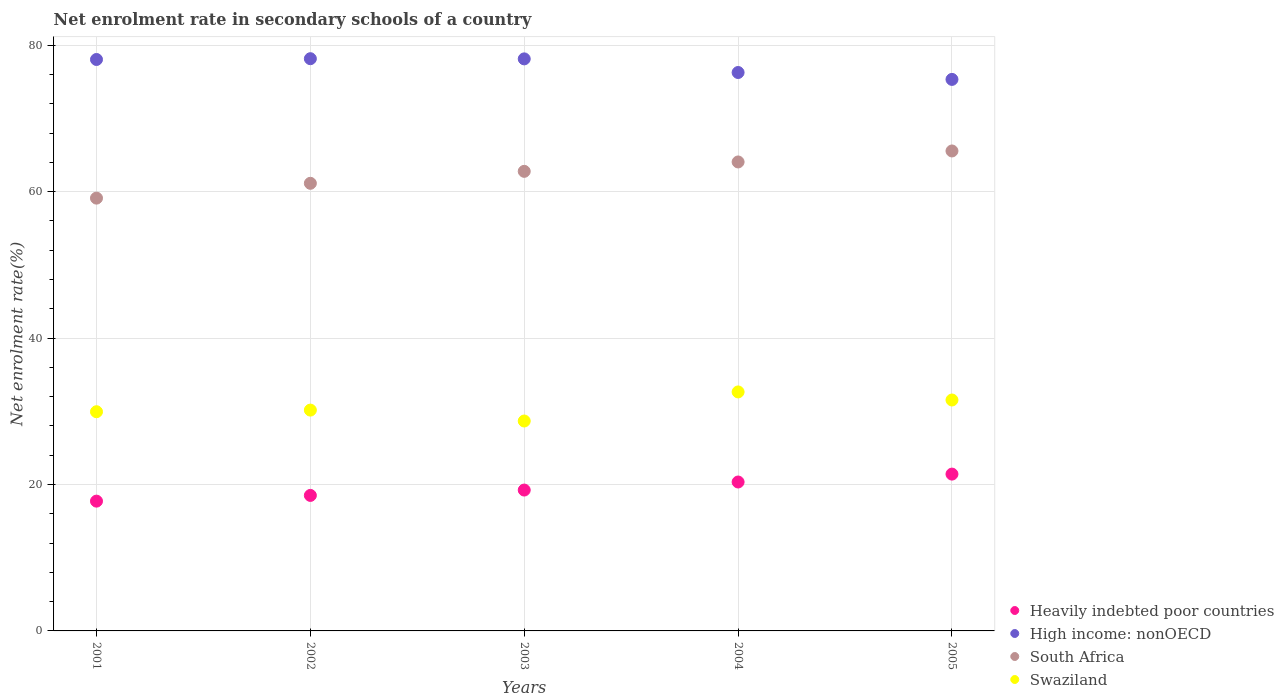Is the number of dotlines equal to the number of legend labels?
Make the answer very short. Yes. What is the net enrolment rate in secondary schools in Swaziland in 2001?
Keep it short and to the point. 29.94. Across all years, what is the maximum net enrolment rate in secondary schools in Heavily indebted poor countries?
Offer a terse response. 21.42. Across all years, what is the minimum net enrolment rate in secondary schools in High income: nonOECD?
Your response must be concise. 75.33. What is the total net enrolment rate in secondary schools in High income: nonOECD in the graph?
Provide a short and direct response. 385.93. What is the difference between the net enrolment rate in secondary schools in Swaziland in 2001 and that in 2003?
Ensure brevity in your answer.  1.27. What is the difference between the net enrolment rate in secondary schools in South Africa in 2001 and the net enrolment rate in secondary schools in Heavily indebted poor countries in 2005?
Your answer should be very brief. 37.69. What is the average net enrolment rate in secondary schools in South Africa per year?
Offer a terse response. 62.52. In the year 2001, what is the difference between the net enrolment rate in secondary schools in Swaziland and net enrolment rate in secondary schools in High income: nonOECD?
Offer a very short reply. -48.11. What is the ratio of the net enrolment rate in secondary schools in Heavily indebted poor countries in 2002 to that in 2005?
Provide a succinct answer. 0.86. What is the difference between the highest and the second highest net enrolment rate in secondary schools in High income: nonOECD?
Offer a very short reply. 0.02. What is the difference between the highest and the lowest net enrolment rate in secondary schools in High income: nonOECD?
Your response must be concise. 2.83. In how many years, is the net enrolment rate in secondary schools in South Africa greater than the average net enrolment rate in secondary schools in South Africa taken over all years?
Keep it short and to the point. 3. Is the sum of the net enrolment rate in secondary schools in Heavily indebted poor countries in 2003 and 2004 greater than the maximum net enrolment rate in secondary schools in Swaziland across all years?
Ensure brevity in your answer.  Yes. Is it the case that in every year, the sum of the net enrolment rate in secondary schools in Swaziland and net enrolment rate in secondary schools in South Africa  is greater than the sum of net enrolment rate in secondary schools in Heavily indebted poor countries and net enrolment rate in secondary schools in High income: nonOECD?
Make the answer very short. No. Does the net enrolment rate in secondary schools in Heavily indebted poor countries monotonically increase over the years?
Offer a very short reply. Yes. What is the difference between two consecutive major ticks on the Y-axis?
Keep it short and to the point. 20. Where does the legend appear in the graph?
Provide a short and direct response. Bottom right. How are the legend labels stacked?
Offer a very short reply. Vertical. What is the title of the graph?
Make the answer very short. Net enrolment rate in secondary schools of a country. Does "Trinidad and Tobago" appear as one of the legend labels in the graph?
Ensure brevity in your answer.  No. What is the label or title of the Y-axis?
Offer a terse response. Net enrolment rate(%). What is the Net enrolment rate(%) in Heavily indebted poor countries in 2001?
Provide a succinct answer. 17.73. What is the Net enrolment rate(%) in High income: nonOECD in 2001?
Give a very brief answer. 78.05. What is the Net enrolment rate(%) in South Africa in 2001?
Provide a succinct answer. 59.11. What is the Net enrolment rate(%) of Swaziland in 2001?
Ensure brevity in your answer.  29.94. What is the Net enrolment rate(%) of Heavily indebted poor countries in 2002?
Provide a short and direct response. 18.51. What is the Net enrolment rate(%) in High income: nonOECD in 2002?
Your answer should be compact. 78.16. What is the Net enrolment rate(%) of South Africa in 2002?
Provide a short and direct response. 61.14. What is the Net enrolment rate(%) in Swaziland in 2002?
Your answer should be compact. 30.16. What is the Net enrolment rate(%) of Heavily indebted poor countries in 2003?
Offer a very short reply. 19.24. What is the Net enrolment rate(%) in High income: nonOECD in 2003?
Offer a terse response. 78.13. What is the Net enrolment rate(%) in South Africa in 2003?
Provide a succinct answer. 62.77. What is the Net enrolment rate(%) of Swaziland in 2003?
Provide a short and direct response. 28.67. What is the Net enrolment rate(%) in Heavily indebted poor countries in 2004?
Provide a short and direct response. 20.34. What is the Net enrolment rate(%) of High income: nonOECD in 2004?
Keep it short and to the point. 76.27. What is the Net enrolment rate(%) of South Africa in 2004?
Keep it short and to the point. 64.05. What is the Net enrolment rate(%) in Swaziland in 2004?
Your answer should be very brief. 32.64. What is the Net enrolment rate(%) of Heavily indebted poor countries in 2005?
Provide a short and direct response. 21.42. What is the Net enrolment rate(%) in High income: nonOECD in 2005?
Give a very brief answer. 75.33. What is the Net enrolment rate(%) of South Africa in 2005?
Offer a terse response. 65.55. What is the Net enrolment rate(%) in Swaziland in 2005?
Keep it short and to the point. 31.54. Across all years, what is the maximum Net enrolment rate(%) of Heavily indebted poor countries?
Offer a very short reply. 21.42. Across all years, what is the maximum Net enrolment rate(%) in High income: nonOECD?
Your response must be concise. 78.16. Across all years, what is the maximum Net enrolment rate(%) of South Africa?
Offer a terse response. 65.55. Across all years, what is the maximum Net enrolment rate(%) in Swaziland?
Your answer should be compact. 32.64. Across all years, what is the minimum Net enrolment rate(%) in Heavily indebted poor countries?
Make the answer very short. 17.73. Across all years, what is the minimum Net enrolment rate(%) in High income: nonOECD?
Provide a succinct answer. 75.33. Across all years, what is the minimum Net enrolment rate(%) of South Africa?
Offer a very short reply. 59.11. Across all years, what is the minimum Net enrolment rate(%) of Swaziland?
Provide a short and direct response. 28.67. What is the total Net enrolment rate(%) of Heavily indebted poor countries in the graph?
Ensure brevity in your answer.  97.23. What is the total Net enrolment rate(%) in High income: nonOECD in the graph?
Give a very brief answer. 385.93. What is the total Net enrolment rate(%) in South Africa in the graph?
Make the answer very short. 312.62. What is the total Net enrolment rate(%) in Swaziland in the graph?
Provide a succinct answer. 152.95. What is the difference between the Net enrolment rate(%) of Heavily indebted poor countries in 2001 and that in 2002?
Offer a terse response. -0.78. What is the difference between the Net enrolment rate(%) in High income: nonOECD in 2001 and that in 2002?
Your answer should be very brief. -0.11. What is the difference between the Net enrolment rate(%) of South Africa in 2001 and that in 2002?
Make the answer very short. -2.02. What is the difference between the Net enrolment rate(%) of Swaziland in 2001 and that in 2002?
Offer a very short reply. -0.22. What is the difference between the Net enrolment rate(%) in Heavily indebted poor countries in 2001 and that in 2003?
Provide a short and direct response. -1.51. What is the difference between the Net enrolment rate(%) of High income: nonOECD in 2001 and that in 2003?
Your response must be concise. -0.08. What is the difference between the Net enrolment rate(%) in South Africa in 2001 and that in 2003?
Your response must be concise. -3.66. What is the difference between the Net enrolment rate(%) of Swaziland in 2001 and that in 2003?
Give a very brief answer. 1.27. What is the difference between the Net enrolment rate(%) in Heavily indebted poor countries in 2001 and that in 2004?
Keep it short and to the point. -2.61. What is the difference between the Net enrolment rate(%) of High income: nonOECD in 2001 and that in 2004?
Make the answer very short. 1.78. What is the difference between the Net enrolment rate(%) of South Africa in 2001 and that in 2004?
Your answer should be compact. -4.94. What is the difference between the Net enrolment rate(%) of Swaziland in 2001 and that in 2004?
Offer a terse response. -2.7. What is the difference between the Net enrolment rate(%) of Heavily indebted poor countries in 2001 and that in 2005?
Provide a short and direct response. -3.69. What is the difference between the Net enrolment rate(%) in High income: nonOECD in 2001 and that in 2005?
Give a very brief answer. 2.72. What is the difference between the Net enrolment rate(%) of South Africa in 2001 and that in 2005?
Make the answer very short. -6.44. What is the difference between the Net enrolment rate(%) in Swaziland in 2001 and that in 2005?
Give a very brief answer. -1.6. What is the difference between the Net enrolment rate(%) in Heavily indebted poor countries in 2002 and that in 2003?
Provide a succinct answer. -0.73. What is the difference between the Net enrolment rate(%) in High income: nonOECD in 2002 and that in 2003?
Give a very brief answer. 0.02. What is the difference between the Net enrolment rate(%) of South Africa in 2002 and that in 2003?
Keep it short and to the point. -1.63. What is the difference between the Net enrolment rate(%) in Swaziland in 2002 and that in 2003?
Make the answer very short. 1.49. What is the difference between the Net enrolment rate(%) of Heavily indebted poor countries in 2002 and that in 2004?
Offer a very short reply. -1.83. What is the difference between the Net enrolment rate(%) in High income: nonOECD in 2002 and that in 2004?
Provide a succinct answer. 1.89. What is the difference between the Net enrolment rate(%) of South Africa in 2002 and that in 2004?
Your answer should be very brief. -2.92. What is the difference between the Net enrolment rate(%) in Swaziland in 2002 and that in 2004?
Provide a succinct answer. -2.48. What is the difference between the Net enrolment rate(%) in Heavily indebted poor countries in 2002 and that in 2005?
Ensure brevity in your answer.  -2.91. What is the difference between the Net enrolment rate(%) of High income: nonOECD in 2002 and that in 2005?
Provide a short and direct response. 2.83. What is the difference between the Net enrolment rate(%) of South Africa in 2002 and that in 2005?
Provide a succinct answer. -4.42. What is the difference between the Net enrolment rate(%) of Swaziland in 2002 and that in 2005?
Provide a succinct answer. -1.38. What is the difference between the Net enrolment rate(%) of Heavily indebted poor countries in 2003 and that in 2004?
Make the answer very short. -1.1. What is the difference between the Net enrolment rate(%) in High income: nonOECD in 2003 and that in 2004?
Offer a very short reply. 1.86. What is the difference between the Net enrolment rate(%) in South Africa in 2003 and that in 2004?
Your answer should be very brief. -1.28. What is the difference between the Net enrolment rate(%) of Swaziland in 2003 and that in 2004?
Your response must be concise. -3.97. What is the difference between the Net enrolment rate(%) in Heavily indebted poor countries in 2003 and that in 2005?
Your answer should be very brief. -2.18. What is the difference between the Net enrolment rate(%) of High income: nonOECD in 2003 and that in 2005?
Your response must be concise. 2.8. What is the difference between the Net enrolment rate(%) of South Africa in 2003 and that in 2005?
Offer a very short reply. -2.78. What is the difference between the Net enrolment rate(%) of Swaziland in 2003 and that in 2005?
Keep it short and to the point. -2.87. What is the difference between the Net enrolment rate(%) in Heavily indebted poor countries in 2004 and that in 2005?
Provide a short and direct response. -1.08. What is the difference between the Net enrolment rate(%) in High income: nonOECD in 2004 and that in 2005?
Provide a short and direct response. 0.94. What is the difference between the Net enrolment rate(%) in Swaziland in 2004 and that in 2005?
Ensure brevity in your answer.  1.1. What is the difference between the Net enrolment rate(%) in Heavily indebted poor countries in 2001 and the Net enrolment rate(%) in High income: nonOECD in 2002?
Keep it short and to the point. -60.43. What is the difference between the Net enrolment rate(%) in Heavily indebted poor countries in 2001 and the Net enrolment rate(%) in South Africa in 2002?
Your answer should be very brief. -43.41. What is the difference between the Net enrolment rate(%) in Heavily indebted poor countries in 2001 and the Net enrolment rate(%) in Swaziland in 2002?
Make the answer very short. -12.43. What is the difference between the Net enrolment rate(%) in High income: nonOECD in 2001 and the Net enrolment rate(%) in South Africa in 2002?
Your answer should be very brief. 16.91. What is the difference between the Net enrolment rate(%) of High income: nonOECD in 2001 and the Net enrolment rate(%) of Swaziland in 2002?
Keep it short and to the point. 47.89. What is the difference between the Net enrolment rate(%) in South Africa in 2001 and the Net enrolment rate(%) in Swaziland in 2002?
Offer a terse response. 28.95. What is the difference between the Net enrolment rate(%) of Heavily indebted poor countries in 2001 and the Net enrolment rate(%) of High income: nonOECD in 2003?
Make the answer very short. -60.4. What is the difference between the Net enrolment rate(%) in Heavily indebted poor countries in 2001 and the Net enrolment rate(%) in South Africa in 2003?
Offer a very short reply. -45.04. What is the difference between the Net enrolment rate(%) in Heavily indebted poor countries in 2001 and the Net enrolment rate(%) in Swaziland in 2003?
Provide a short and direct response. -10.94. What is the difference between the Net enrolment rate(%) in High income: nonOECD in 2001 and the Net enrolment rate(%) in South Africa in 2003?
Your answer should be very brief. 15.28. What is the difference between the Net enrolment rate(%) of High income: nonOECD in 2001 and the Net enrolment rate(%) of Swaziland in 2003?
Keep it short and to the point. 49.38. What is the difference between the Net enrolment rate(%) of South Africa in 2001 and the Net enrolment rate(%) of Swaziland in 2003?
Provide a succinct answer. 30.44. What is the difference between the Net enrolment rate(%) of Heavily indebted poor countries in 2001 and the Net enrolment rate(%) of High income: nonOECD in 2004?
Offer a terse response. -58.54. What is the difference between the Net enrolment rate(%) in Heavily indebted poor countries in 2001 and the Net enrolment rate(%) in South Africa in 2004?
Offer a terse response. -46.33. What is the difference between the Net enrolment rate(%) of Heavily indebted poor countries in 2001 and the Net enrolment rate(%) of Swaziland in 2004?
Your answer should be compact. -14.92. What is the difference between the Net enrolment rate(%) in High income: nonOECD in 2001 and the Net enrolment rate(%) in South Africa in 2004?
Keep it short and to the point. 13.99. What is the difference between the Net enrolment rate(%) in High income: nonOECD in 2001 and the Net enrolment rate(%) in Swaziland in 2004?
Ensure brevity in your answer.  45.4. What is the difference between the Net enrolment rate(%) of South Africa in 2001 and the Net enrolment rate(%) of Swaziland in 2004?
Make the answer very short. 26.47. What is the difference between the Net enrolment rate(%) in Heavily indebted poor countries in 2001 and the Net enrolment rate(%) in High income: nonOECD in 2005?
Provide a short and direct response. -57.6. What is the difference between the Net enrolment rate(%) in Heavily indebted poor countries in 2001 and the Net enrolment rate(%) in South Africa in 2005?
Your response must be concise. -47.83. What is the difference between the Net enrolment rate(%) in Heavily indebted poor countries in 2001 and the Net enrolment rate(%) in Swaziland in 2005?
Offer a terse response. -13.81. What is the difference between the Net enrolment rate(%) of High income: nonOECD in 2001 and the Net enrolment rate(%) of South Africa in 2005?
Ensure brevity in your answer.  12.49. What is the difference between the Net enrolment rate(%) of High income: nonOECD in 2001 and the Net enrolment rate(%) of Swaziland in 2005?
Make the answer very short. 46.51. What is the difference between the Net enrolment rate(%) of South Africa in 2001 and the Net enrolment rate(%) of Swaziland in 2005?
Your answer should be compact. 27.57. What is the difference between the Net enrolment rate(%) in Heavily indebted poor countries in 2002 and the Net enrolment rate(%) in High income: nonOECD in 2003?
Provide a succinct answer. -59.62. What is the difference between the Net enrolment rate(%) of Heavily indebted poor countries in 2002 and the Net enrolment rate(%) of South Africa in 2003?
Give a very brief answer. -44.26. What is the difference between the Net enrolment rate(%) in Heavily indebted poor countries in 2002 and the Net enrolment rate(%) in Swaziland in 2003?
Offer a terse response. -10.16. What is the difference between the Net enrolment rate(%) of High income: nonOECD in 2002 and the Net enrolment rate(%) of South Africa in 2003?
Ensure brevity in your answer.  15.39. What is the difference between the Net enrolment rate(%) of High income: nonOECD in 2002 and the Net enrolment rate(%) of Swaziland in 2003?
Make the answer very short. 49.48. What is the difference between the Net enrolment rate(%) of South Africa in 2002 and the Net enrolment rate(%) of Swaziland in 2003?
Offer a terse response. 32.47. What is the difference between the Net enrolment rate(%) in Heavily indebted poor countries in 2002 and the Net enrolment rate(%) in High income: nonOECD in 2004?
Offer a terse response. -57.76. What is the difference between the Net enrolment rate(%) of Heavily indebted poor countries in 2002 and the Net enrolment rate(%) of South Africa in 2004?
Keep it short and to the point. -45.55. What is the difference between the Net enrolment rate(%) of Heavily indebted poor countries in 2002 and the Net enrolment rate(%) of Swaziland in 2004?
Provide a succinct answer. -14.13. What is the difference between the Net enrolment rate(%) of High income: nonOECD in 2002 and the Net enrolment rate(%) of South Africa in 2004?
Your response must be concise. 14.1. What is the difference between the Net enrolment rate(%) of High income: nonOECD in 2002 and the Net enrolment rate(%) of Swaziland in 2004?
Provide a short and direct response. 45.51. What is the difference between the Net enrolment rate(%) in South Africa in 2002 and the Net enrolment rate(%) in Swaziland in 2004?
Your answer should be very brief. 28.49. What is the difference between the Net enrolment rate(%) in Heavily indebted poor countries in 2002 and the Net enrolment rate(%) in High income: nonOECD in 2005?
Your response must be concise. -56.82. What is the difference between the Net enrolment rate(%) of Heavily indebted poor countries in 2002 and the Net enrolment rate(%) of South Africa in 2005?
Give a very brief answer. -47.05. What is the difference between the Net enrolment rate(%) of Heavily indebted poor countries in 2002 and the Net enrolment rate(%) of Swaziland in 2005?
Your response must be concise. -13.03. What is the difference between the Net enrolment rate(%) of High income: nonOECD in 2002 and the Net enrolment rate(%) of South Africa in 2005?
Offer a terse response. 12.6. What is the difference between the Net enrolment rate(%) in High income: nonOECD in 2002 and the Net enrolment rate(%) in Swaziland in 2005?
Ensure brevity in your answer.  46.62. What is the difference between the Net enrolment rate(%) of South Africa in 2002 and the Net enrolment rate(%) of Swaziland in 2005?
Give a very brief answer. 29.6. What is the difference between the Net enrolment rate(%) in Heavily indebted poor countries in 2003 and the Net enrolment rate(%) in High income: nonOECD in 2004?
Make the answer very short. -57.03. What is the difference between the Net enrolment rate(%) of Heavily indebted poor countries in 2003 and the Net enrolment rate(%) of South Africa in 2004?
Give a very brief answer. -44.81. What is the difference between the Net enrolment rate(%) in Heavily indebted poor countries in 2003 and the Net enrolment rate(%) in Swaziland in 2004?
Your response must be concise. -13.4. What is the difference between the Net enrolment rate(%) in High income: nonOECD in 2003 and the Net enrolment rate(%) in South Africa in 2004?
Ensure brevity in your answer.  14.08. What is the difference between the Net enrolment rate(%) of High income: nonOECD in 2003 and the Net enrolment rate(%) of Swaziland in 2004?
Your answer should be very brief. 45.49. What is the difference between the Net enrolment rate(%) in South Africa in 2003 and the Net enrolment rate(%) in Swaziland in 2004?
Your response must be concise. 30.13. What is the difference between the Net enrolment rate(%) of Heavily indebted poor countries in 2003 and the Net enrolment rate(%) of High income: nonOECD in 2005?
Give a very brief answer. -56.09. What is the difference between the Net enrolment rate(%) in Heavily indebted poor countries in 2003 and the Net enrolment rate(%) in South Africa in 2005?
Your response must be concise. -46.31. What is the difference between the Net enrolment rate(%) of High income: nonOECD in 2003 and the Net enrolment rate(%) of South Africa in 2005?
Offer a terse response. 12.58. What is the difference between the Net enrolment rate(%) in High income: nonOECD in 2003 and the Net enrolment rate(%) in Swaziland in 2005?
Your response must be concise. 46.59. What is the difference between the Net enrolment rate(%) in South Africa in 2003 and the Net enrolment rate(%) in Swaziland in 2005?
Your answer should be very brief. 31.23. What is the difference between the Net enrolment rate(%) in Heavily indebted poor countries in 2004 and the Net enrolment rate(%) in High income: nonOECD in 2005?
Provide a succinct answer. -54.99. What is the difference between the Net enrolment rate(%) of Heavily indebted poor countries in 2004 and the Net enrolment rate(%) of South Africa in 2005?
Your answer should be compact. -45.21. What is the difference between the Net enrolment rate(%) of Heavily indebted poor countries in 2004 and the Net enrolment rate(%) of Swaziland in 2005?
Provide a short and direct response. -11.2. What is the difference between the Net enrolment rate(%) of High income: nonOECD in 2004 and the Net enrolment rate(%) of South Africa in 2005?
Your answer should be compact. 10.72. What is the difference between the Net enrolment rate(%) in High income: nonOECD in 2004 and the Net enrolment rate(%) in Swaziland in 2005?
Offer a terse response. 44.73. What is the difference between the Net enrolment rate(%) in South Africa in 2004 and the Net enrolment rate(%) in Swaziland in 2005?
Your response must be concise. 32.51. What is the average Net enrolment rate(%) in Heavily indebted poor countries per year?
Keep it short and to the point. 19.45. What is the average Net enrolment rate(%) of High income: nonOECD per year?
Make the answer very short. 77.19. What is the average Net enrolment rate(%) of South Africa per year?
Make the answer very short. 62.52. What is the average Net enrolment rate(%) of Swaziland per year?
Offer a very short reply. 30.59. In the year 2001, what is the difference between the Net enrolment rate(%) of Heavily indebted poor countries and Net enrolment rate(%) of High income: nonOECD?
Your response must be concise. -60.32. In the year 2001, what is the difference between the Net enrolment rate(%) in Heavily indebted poor countries and Net enrolment rate(%) in South Africa?
Your response must be concise. -41.39. In the year 2001, what is the difference between the Net enrolment rate(%) of Heavily indebted poor countries and Net enrolment rate(%) of Swaziland?
Provide a short and direct response. -12.21. In the year 2001, what is the difference between the Net enrolment rate(%) in High income: nonOECD and Net enrolment rate(%) in South Africa?
Make the answer very short. 18.94. In the year 2001, what is the difference between the Net enrolment rate(%) of High income: nonOECD and Net enrolment rate(%) of Swaziland?
Offer a terse response. 48.11. In the year 2001, what is the difference between the Net enrolment rate(%) of South Africa and Net enrolment rate(%) of Swaziland?
Your answer should be very brief. 29.17. In the year 2002, what is the difference between the Net enrolment rate(%) in Heavily indebted poor countries and Net enrolment rate(%) in High income: nonOECD?
Offer a terse response. -59.65. In the year 2002, what is the difference between the Net enrolment rate(%) of Heavily indebted poor countries and Net enrolment rate(%) of South Africa?
Give a very brief answer. -42.63. In the year 2002, what is the difference between the Net enrolment rate(%) in Heavily indebted poor countries and Net enrolment rate(%) in Swaziland?
Provide a succinct answer. -11.65. In the year 2002, what is the difference between the Net enrolment rate(%) of High income: nonOECD and Net enrolment rate(%) of South Africa?
Your response must be concise. 17.02. In the year 2002, what is the difference between the Net enrolment rate(%) of High income: nonOECD and Net enrolment rate(%) of Swaziland?
Offer a very short reply. 47.99. In the year 2002, what is the difference between the Net enrolment rate(%) in South Africa and Net enrolment rate(%) in Swaziland?
Provide a succinct answer. 30.98. In the year 2003, what is the difference between the Net enrolment rate(%) of Heavily indebted poor countries and Net enrolment rate(%) of High income: nonOECD?
Offer a very short reply. -58.89. In the year 2003, what is the difference between the Net enrolment rate(%) in Heavily indebted poor countries and Net enrolment rate(%) in South Africa?
Make the answer very short. -43.53. In the year 2003, what is the difference between the Net enrolment rate(%) of Heavily indebted poor countries and Net enrolment rate(%) of Swaziland?
Offer a very short reply. -9.43. In the year 2003, what is the difference between the Net enrolment rate(%) of High income: nonOECD and Net enrolment rate(%) of South Africa?
Your answer should be very brief. 15.36. In the year 2003, what is the difference between the Net enrolment rate(%) in High income: nonOECD and Net enrolment rate(%) in Swaziland?
Your answer should be compact. 49.46. In the year 2003, what is the difference between the Net enrolment rate(%) of South Africa and Net enrolment rate(%) of Swaziland?
Your answer should be compact. 34.1. In the year 2004, what is the difference between the Net enrolment rate(%) in Heavily indebted poor countries and Net enrolment rate(%) in High income: nonOECD?
Give a very brief answer. -55.93. In the year 2004, what is the difference between the Net enrolment rate(%) in Heavily indebted poor countries and Net enrolment rate(%) in South Africa?
Keep it short and to the point. -43.71. In the year 2004, what is the difference between the Net enrolment rate(%) of Heavily indebted poor countries and Net enrolment rate(%) of Swaziland?
Provide a short and direct response. -12.3. In the year 2004, what is the difference between the Net enrolment rate(%) in High income: nonOECD and Net enrolment rate(%) in South Africa?
Your response must be concise. 12.22. In the year 2004, what is the difference between the Net enrolment rate(%) of High income: nonOECD and Net enrolment rate(%) of Swaziland?
Make the answer very short. 43.63. In the year 2004, what is the difference between the Net enrolment rate(%) of South Africa and Net enrolment rate(%) of Swaziland?
Offer a terse response. 31.41. In the year 2005, what is the difference between the Net enrolment rate(%) in Heavily indebted poor countries and Net enrolment rate(%) in High income: nonOECD?
Give a very brief answer. -53.91. In the year 2005, what is the difference between the Net enrolment rate(%) of Heavily indebted poor countries and Net enrolment rate(%) of South Africa?
Give a very brief answer. -44.13. In the year 2005, what is the difference between the Net enrolment rate(%) in Heavily indebted poor countries and Net enrolment rate(%) in Swaziland?
Make the answer very short. -10.12. In the year 2005, what is the difference between the Net enrolment rate(%) of High income: nonOECD and Net enrolment rate(%) of South Africa?
Ensure brevity in your answer.  9.77. In the year 2005, what is the difference between the Net enrolment rate(%) of High income: nonOECD and Net enrolment rate(%) of Swaziland?
Give a very brief answer. 43.79. In the year 2005, what is the difference between the Net enrolment rate(%) of South Africa and Net enrolment rate(%) of Swaziland?
Offer a very short reply. 34.01. What is the ratio of the Net enrolment rate(%) of Heavily indebted poor countries in 2001 to that in 2002?
Ensure brevity in your answer.  0.96. What is the ratio of the Net enrolment rate(%) in High income: nonOECD in 2001 to that in 2002?
Your answer should be compact. 1. What is the ratio of the Net enrolment rate(%) in South Africa in 2001 to that in 2002?
Provide a short and direct response. 0.97. What is the ratio of the Net enrolment rate(%) in Heavily indebted poor countries in 2001 to that in 2003?
Ensure brevity in your answer.  0.92. What is the ratio of the Net enrolment rate(%) in High income: nonOECD in 2001 to that in 2003?
Give a very brief answer. 1. What is the ratio of the Net enrolment rate(%) in South Africa in 2001 to that in 2003?
Keep it short and to the point. 0.94. What is the ratio of the Net enrolment rate(%) of Swaziland in 2001 to that in 2003?
Your answer should be very brief. 1.04. What is the ratio of the Net enrolment rate(%) in Heavily indebted poor countries in 2001 to that in 2004?
Ensure brevity in your answer.  0.87. What is the ratio of the Net enrolment rate(%) of High income: nonOECD in 2001 to that in 2004?
Your response must be concise. 1.02. What is the ratio of the Net enrolment rate(%) of South Africa in 2001 to that in 2004?
Keep it short and to the point. 0.92. What is the ratio of the Net enrolment rate(%) of Swaziland in 2001 to that in 2004?
Provide a succinct answer. 0.92. What is the ratio of the Net enrolment rate(%) of Heavily indebted poor countries in 2001 to that in 2005?
Make the answer very short. 0.83. What is the ratio of the Net enrolment rate(%) in High income: nonOECD in 2001 to that in 2005?
Provide a succinct answer. 1.04. What is the ratio of the Net enrolment rate(%) in South Africa in 2001 to that in 2005?
Offer a terse response. 0.9. What is the ratio of the Net enrolment rate(%) in Swaziland in 2001 to that in 2005?
Provide a short and direct response. 0.95. What is the ratio of the Net enrolment rate(%) in Swaziland in 2002 to that in 2003?
Provide a short and direct response. 1.05. What is the ratio of the Net enrolment rate(%) of Heavily indebted poor countries in 2002 to that in 2004?
Provide a short and direct response. 0.91. What is the ratio of the Net enrolment rate(%) of High income: nonOECD in 2002 to that in 2004?
Your answer should be very brief. 1.02. What is the ratio of the Net enrolment rate(%) of South Africa in 2002 to that in 2004?
Offer a terse response. 0.95. What is the ratio of the Net enrolment rate(%) in Swaziland in 2002 to that in 2004?
Your answer should be compact. 0.92. What is the ratio of the Net enrolment rate(%) in Heavily indebted poor countries in 2002 to that in 2005?
Give a very brief answer. 0.86. What is the ratio of the Net enrolment rate(%) of High income: nonOECD in 2002 to that in 2005?
Give a very brief answer. 1.04. What is the ratio of the Net enrolment rate(%) in South Africa in 2002 to that in 2005?
Your answer should be compact. 0.93. What is the ratio of the Net enrolment rate(%) of Swaziland in 2002 to that in 2005?
Ensure brevity in your answer.  0.96. What is the ratio of the Net enrolment rate(%) in Heavily indebted poor countries in 2003 to that in 2004?
Your answer should be compact. 0.95. What is the ratio of the Net enrolment rate(%) in High income: nonOECD in 2003 to that in 2004?
Ensure brevity in your answer.  1.02. What is the ratio of the Net enrolment rate(%) in South Africa in 2003 to that in 2004?
Provide a short and direct response. 0.98. What is the ratio of the Net enrolment rate(%) of Swaziland in 2003 to that in 2004?
Give a very brief answer. 0.88. What is the ratio of the Net enrolment rate(%) of Heavily indebted poor countries in 2003 to that in 2005?
Provide a succinct answer. 0.9. What is the ratio of the Net enrolment rate(%) in High income: nonOECD in 2003 to that in 2005?
Your answer should be compact. 1.04. What is the ratio of the Net enrolment rate(%) of South Africa in 2003 to that in 2005?
Your response must be concise. 0.96. What is the ratio of the Net enrolment rate(%) in Swaziland in 2003 to that in 2005?
Your response must be concise. 0.91. What is the ratio of the Net enrolment rate(%) of Heavily indebted poor countries in 2004 to that in 2005?
Your answer should be very brief. 0.95. What is the ratio of the Net enrolment rate(%) of High income: nonOECD in 2004 to that in 2005?
Your response must be concise. 1.01. What is the ratio of the Net enrolment rate(%) of South Africa in 2004 to that in 2005?
Make the answer very short. 0.98. What is the ratio of the Net enrolment rate(%) in Swaziland in 2004 to that in 2005?
Offer a very short reply. 1.03. What is the difference between the highest and the second highest Net enrolment rate(%) of Heavily indebted poor countries?
Provide a short and direct response. 1.08. What is the difference between the highest and the second highest Net enrolment rate(%) of High income: nonOECD?
Give a very brief answer. 0.02. What is the difference between the highest and the second highest Net enrolment rate(%) in Swaziland?
Provide a short and direct response. 1.1. What is the difference between the highest and the lowest Net enrolment rate(%) of Heavily indebted poor countries?
Offer a terse response. 3.69. What is the difference between the highest and the lowest Net enrolment rate(%) of High income: nonOECD?
Your answer should be very brief. 2.83. What is the difference between the highest and the lowest Net enrolment rate(%) of South Africa?
Your response must be concise. 6.44. What is the difference between the highest and the lowest Net enrolment rate(%) of Swaziland?
Give a very brief answer. 3.97. 